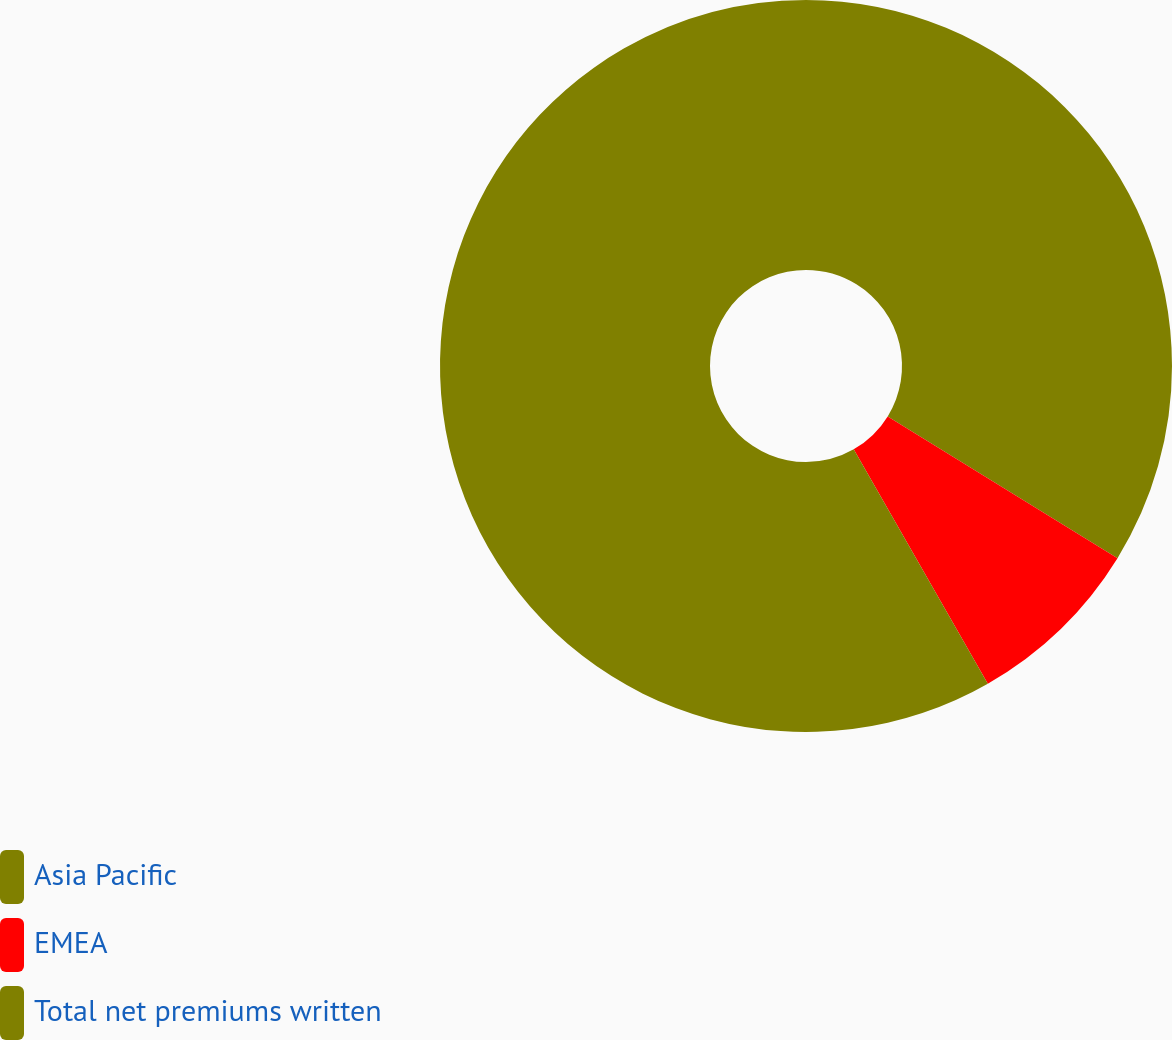Convert chart to OTSL. <chart><loc_0><loc_0><loc_500><loc_500><pie_chart><fcel>Asia Pacific<fcel>EMEA<fcel>Total net premiums written<nl><fcel>33.8%<fcel>7.93%<fcel>58.28%<nl></chart> 